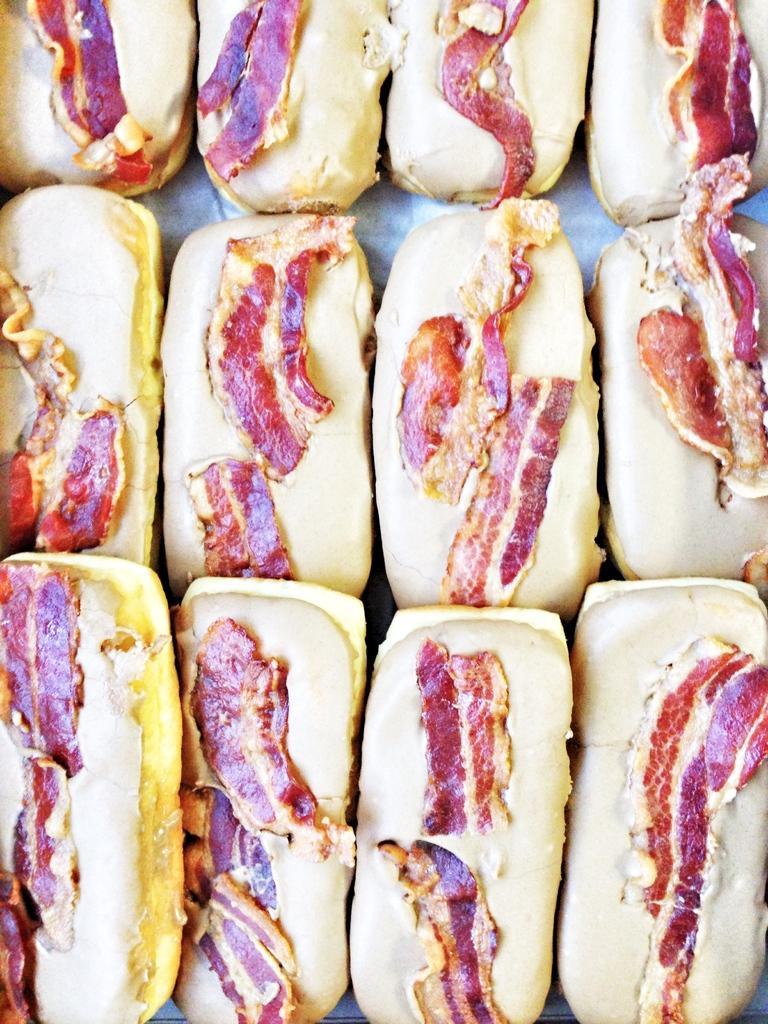How would you summarize this image in a sentence or two? In this image there are some food items, on the food items there are some meat slices. 